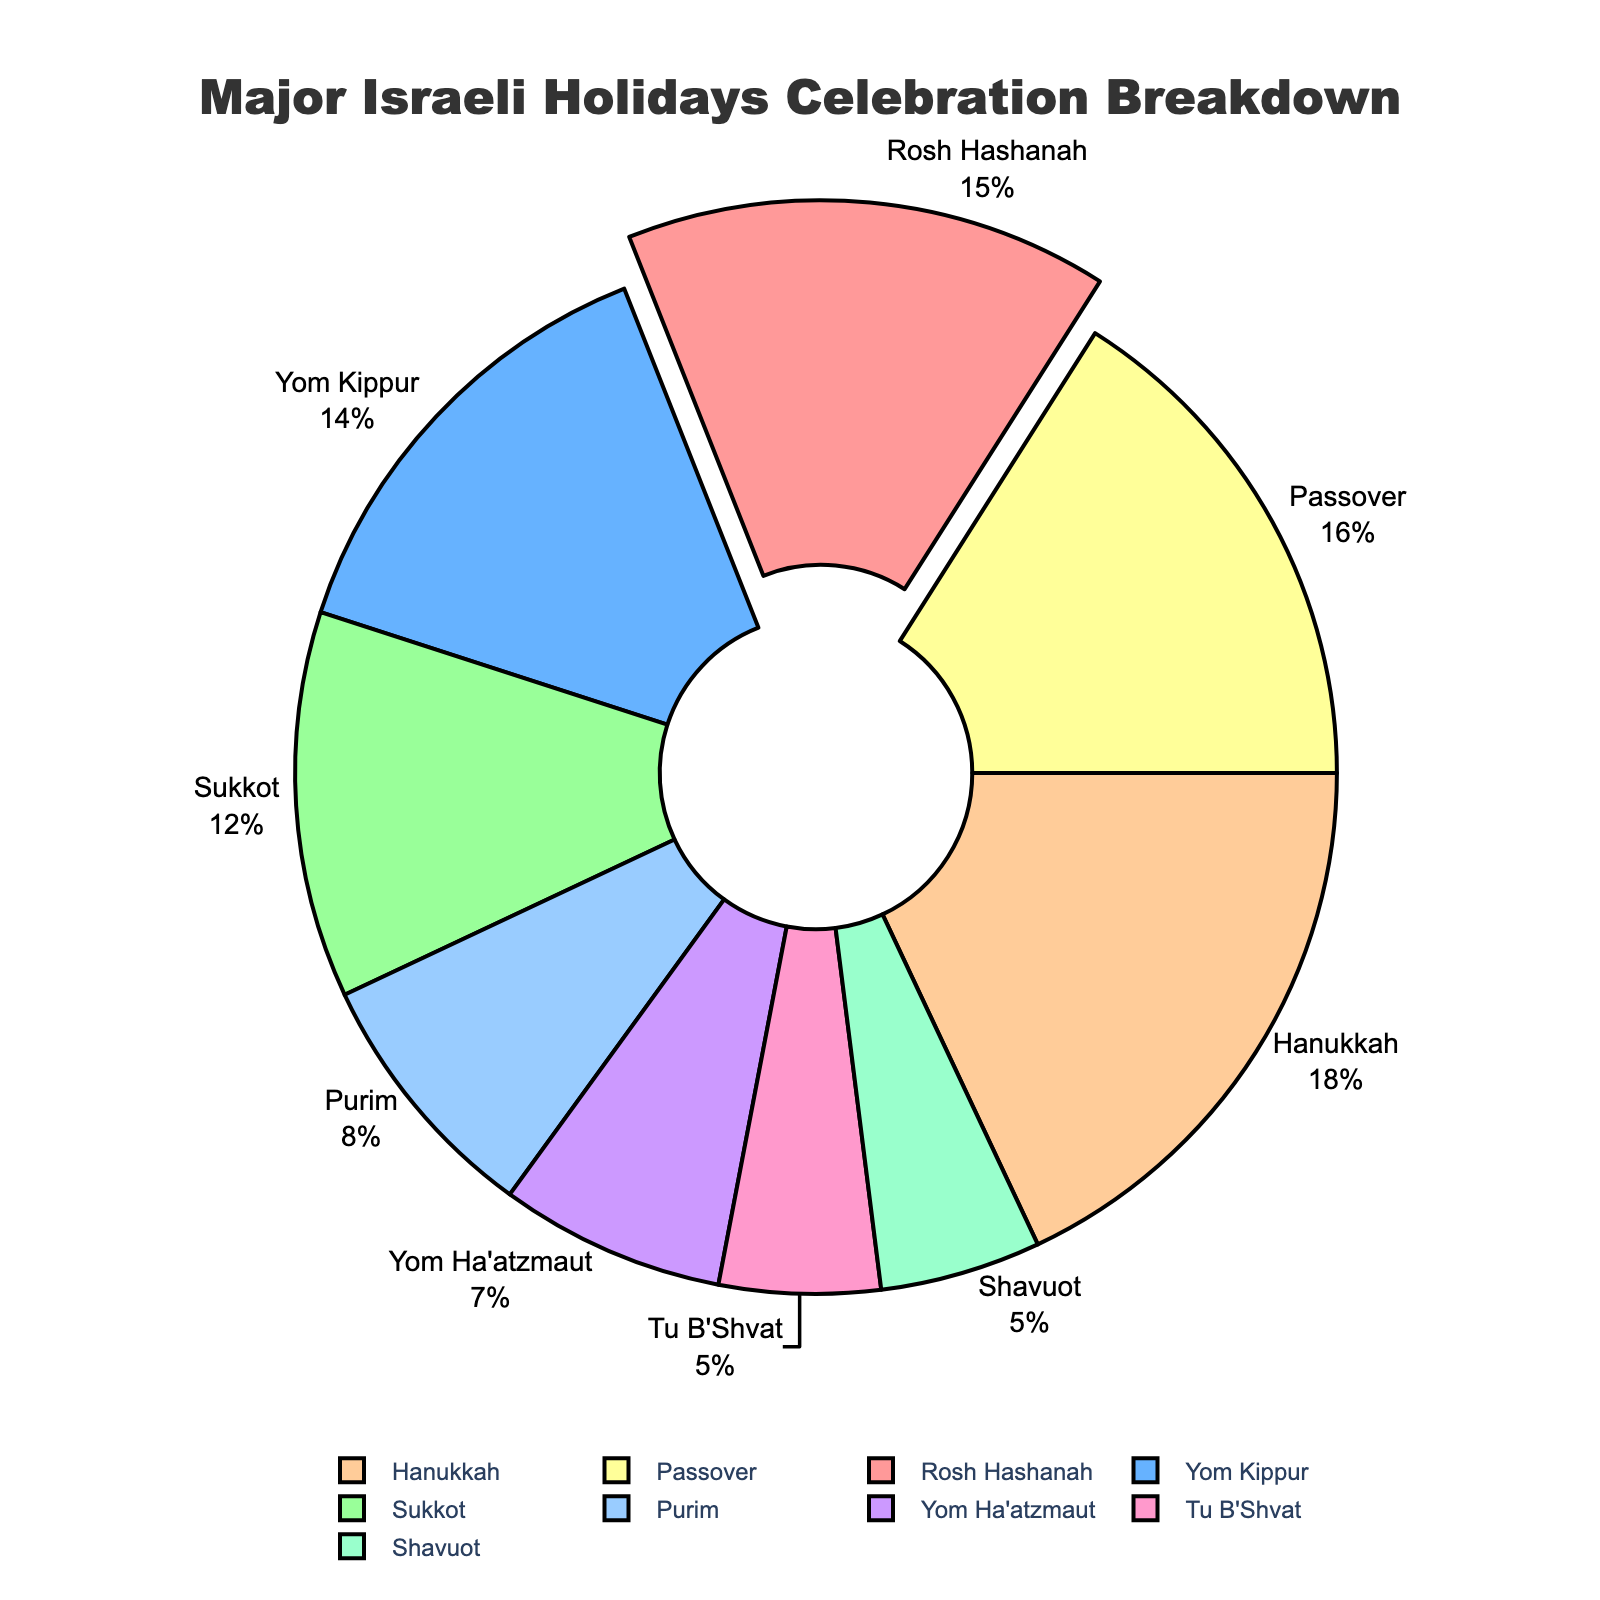Which holiday has the highest percentage of celebration? By visually inspecting the pie chart, Hanukkah occupies the largest segment of the pie chart.
Answer: Hanukkah Which holidays are celebrated more than Passover? By comparing the sizes of the segments, Hanukkah (18%) and Rosh Hashanah (15%) are the only holidays with a greater percentage than Passover (16%).
Answer: Hanukkah, Rosh Hashanah How much more is Hanukkah celebrated compared to Purim? Hanukkah's segment is labeled as 18% and Purim's segment as 8%. Subtracting Purim's percentage from Hanukkah's: 18% - 8% = 10%.
Answer: 10% What is the combined percentage of Rosh Hashanah and Yom Kippur celebrations? Rosh Hashanah has 15% and Yom Kippur has 14%. Adding these percentages together: 15% + 14% = 29%.
Answer: 29% Which holiday is celebrated equally as much as Shavuot? By looking at the pie chart, Tu B'Shvat is also labeled with 5%, the same as Shavuot.
Answer: Tu B'Shvat What is the total percentage of holidays celebrated less than 10%? Adding the percentages of Tu B'Shvat (5%), Purim (8%), Yom Ha'atzmaut (7%), and Shavuot (5%): 5% + 8% + 7% + 5% = 25%.
Answer: 25% Which holiday is represented by a segment with a purple hue? By examining the colors and labels, Yom Ha'atzmaut appears in a purple hue.
Answer: Yom Ha'atzmaut What's the difference in percentage between the most and least celebrated holidays? Hanukkah is the most celebrated at 18% and Tu B'Shvat and Shavuot are the least celebrated at 5%. Subtracting: 18% - 5% = 13%.
Answer: 13% Are there more holidays celebrated below 10% or above 15%? Below 10%: Tu B'Shvat, Yom Ha'atzmaut, Purim. Above 15%: Hanukkah, Rosh Hashanah, Passover. There are 3 holidays in both categories.
Answer: Equal Which color is associated with the segment representing Sukkot? By visually identifying the sector associated with Sukkot, it is represented by an orange hue.
Answer: Orange 